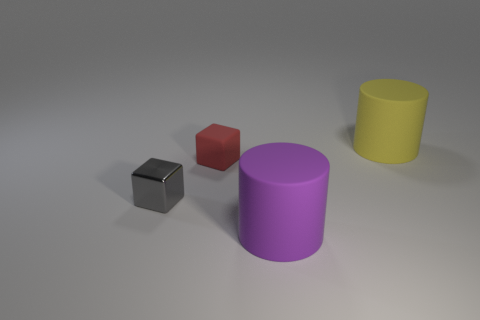Subtract all cyan cylinders. Subtract all cyan spheres. How many cylinders are left? 2 Add 3 gray objects. How many objects exist? 7 Add 1 big yellow rubber cylinders. How many big yellow rubber cylinders are left? 2 Add 1 yellow matte objects. How many yellow matte objects exist? 2 Subtract 0 blue spheres. How many objects are left? 4 Subtract all big yellow matte cylinders. Subtract all tiny shiny blocks. How many objects are left? 2 